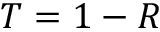<formula> <loc_0><loc_0><loc_500><loc_500>T = 1 - R</formula> 